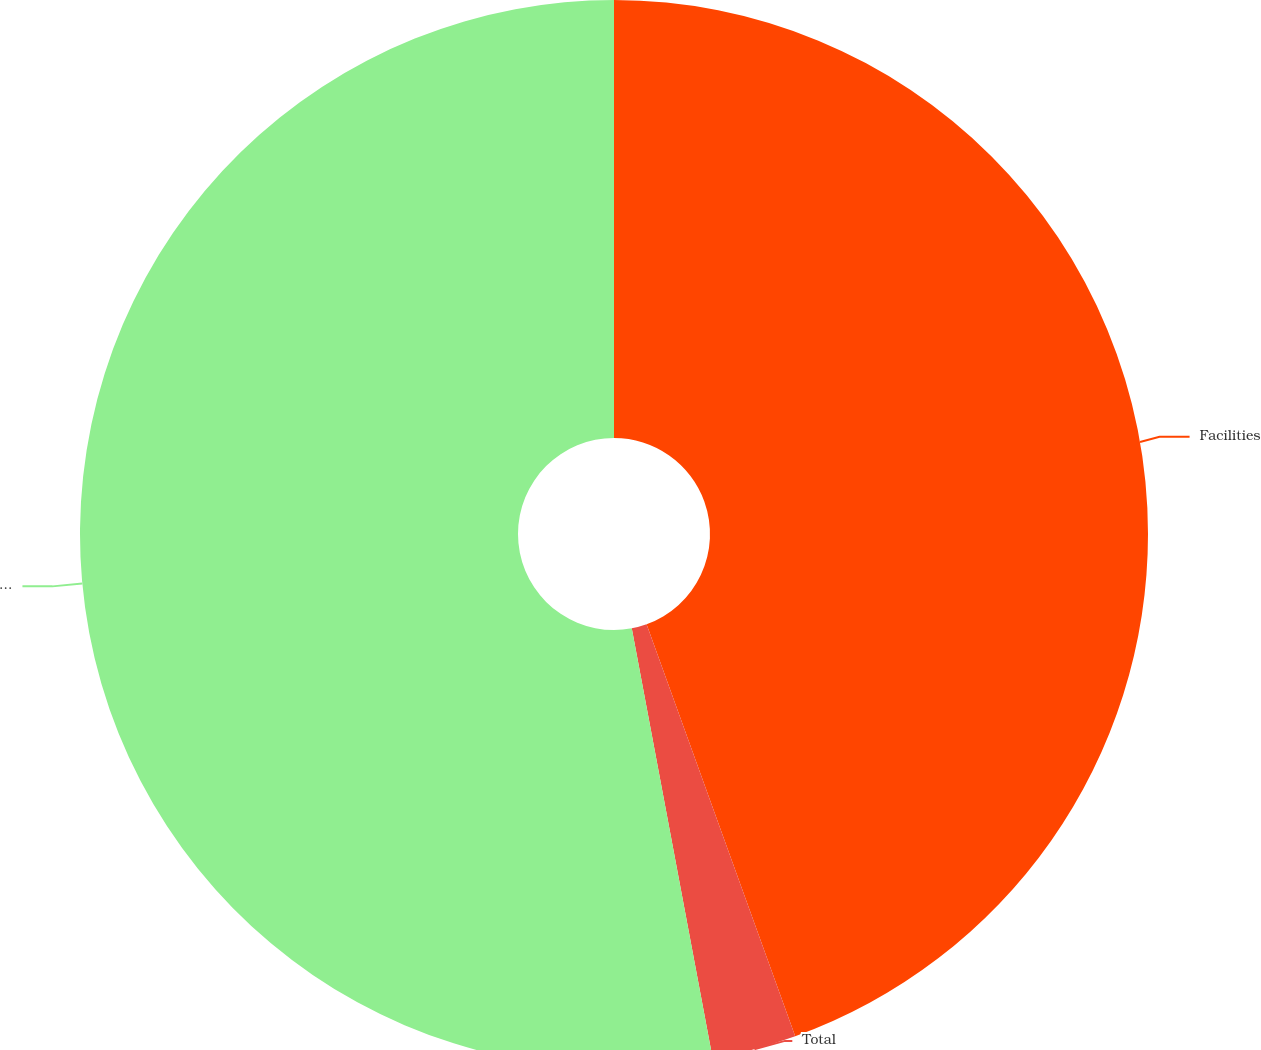Convert chart to OTSL. <chart><loc_0><loc_0><loc_500><loc_500><pie_chart><fcel>Facilities<fcel>Total<fcel>Equipment<nl><fcel>44.49%<fcel>2.55%<fcel>52.96%<nl></chart> 